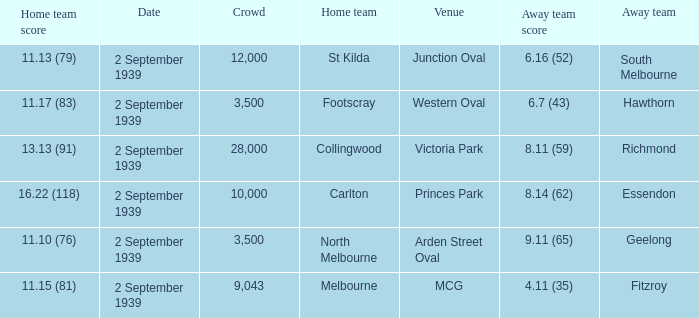What was the crowd size of the match featuring Hawthorn as the Away team? 3500.0. 